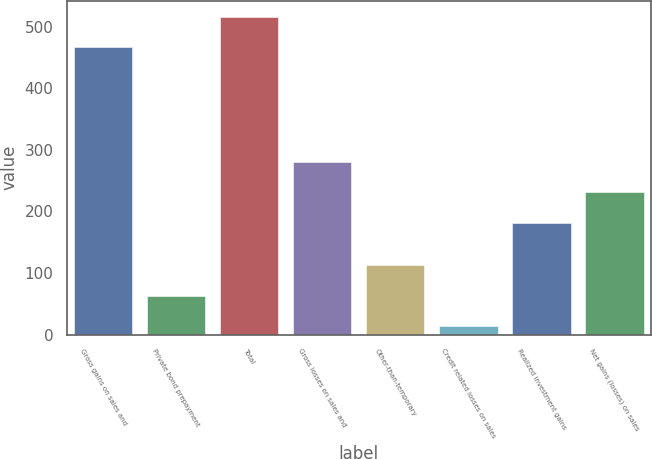Convert chart to OTSL. <chart><loc_0><loc_0><loc_500><loc_500><bar_chart><fcel>Gross gains on sales and<fcel>Private bond prepayment<fcel>Total<fcel>Gross losses on sales and<fcel>Other-than-temporary<fcel>Credit related losses on sales<fcel>Realized investment gains<fcel>Net gains (losses) on sales<nl><fcel>467<fcel>63.2<fcel>516.2<fcel>280.4<fcel>112.4<fcel>14<fcel>182<fcel>231.2<nl></chart> 